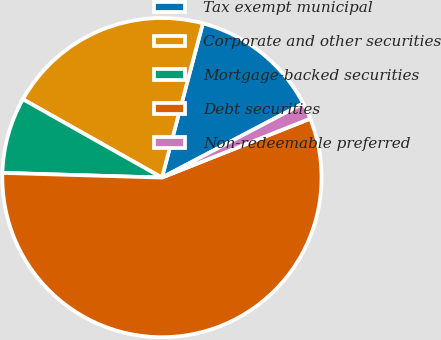Convert chart. <chart><loc_0><loc_0><loc_500><loc_500><pie_chart><fcel>Tax exempt municipal<fcel>Corporate and other securities<fcel>Mortgage-backed securities<fcel>Debt securities<fcel>Non-redeemable preferred<nl><fcel>13.18%<fcel>20.96%<fcel>7.7%<fcel>56.49%<fcel>1.67%<nl></chart> 